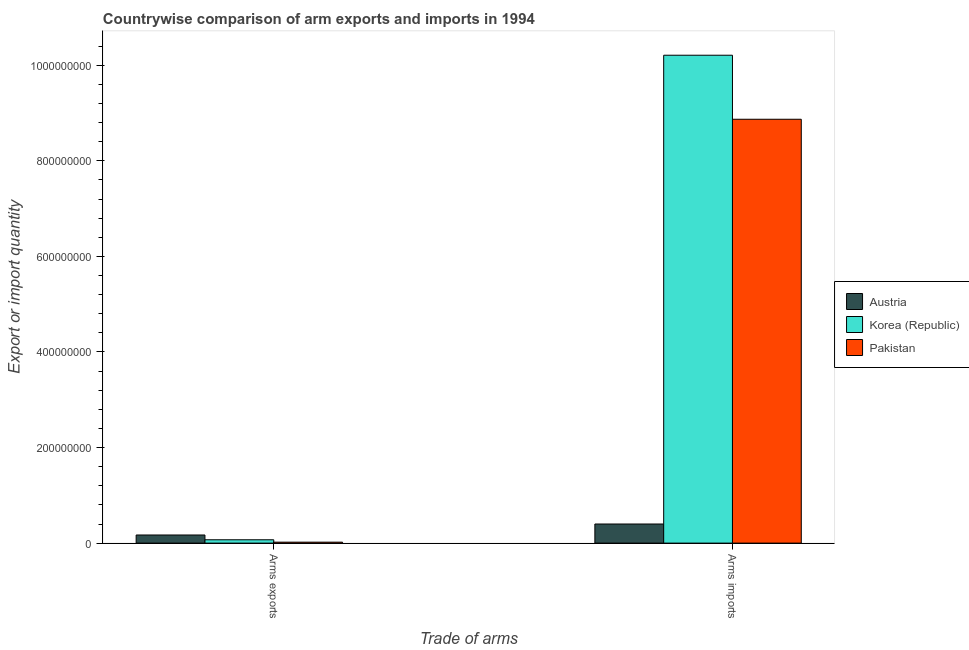Are the number of bars on each tick of the X-axis equal?
Your answer should be compact. Yes. What is the label of the 1st group of bars from the left?
Offer a very short reply. Arms exports. What is the arms imports in Korea (Republic)?
Offer a very short reply. 1.02e+09. Across all countries, what is the maximum arms imports?
Ensure brevity in your answer.  1.02e+09. Across all countries, what is the minimum arms exports?
Ensure brevity in your answer.  2.00e+06. What is the total arms imports in the graph?
Your answer should be very brief. 1.95e+09. What is the difference between the arms imports in Pakistan and that in Austria?
Give a very brief answer. 8.47e+08. What is the difference between the arms exports in Korea (Republic) and the arms imports in Austria?
Offer a very short reply. -3.30e+07. What is the average arms imports per country?
Offer a very short reply. 6.49e+08. What is the difference between the arms imports and arms exports in Pakistan?
Keep it short and to the point. 8.85e+08. What is the ratio of the arms imports in Pakistan to that in Austria?
Ensure brevity in your answer.  22.18. Is the arms imports in Korea (Republic) less than that in Austria?
Offer a terse response. No. What does the 1st bar from the left in Arms exports represents?
Provide a succinct answer. Austria. How many bars are there?
Your response must be concise. 6. Are all the bars in the graph horizontal?
Ensure brevity in your answer.  No. Are the values on the major ticks of Y-axis written in scientific E-notation?
Provide a succinct answer. No. Where does the legend appear in the graph?
Your answer should be very brief. Center right. How many legend labels are there?
Provide a short and direct response. 3. What is the title of the graph?
Keep it short and to the point. Countrywise comparison of arm exports and imports in 1994. What is the label or title of the X-axis?
Offer a very short reply. Trade of arms. What is the label or title of the Y-axis?
Provide a succinct answer. Export or import quantity. What is the Export or import quantity of Austria in Arms exports?
Your response must be concise. 1.70e+07. What is the Export or import quantity of Austria in Arms imports?
Ensure brevity in your answer.  4.00e+07. What is the Export or import quantity of Korea (Republic) in Arms imports?
Your answer should be compact. 1.02e+09. What is the Export or import quantity of Pakistan in Arms imports?
Offer a very short reply. 8.87e+08. Across all Trade of arms, what is the maximum Export or import quantity of Austria?
Give a very brief answer. 4.00e+07. Across all Trade of arms, what is the maximum Export or import quantity in Korea (Republic)?
Your answer should be very brief. 1.02e+09. Across all Trade of arms, what is the maximum Export or import quantity in Pakistan?
Offer a terse response. 8.87e+08. Across all Trade of arms, what is the minimum Export or import quantity of Austria?
Ensure brevity in your answer.  1.70e+07. Across all Trade of arms, what is the minimum Export or import quantity in Pakistan?
Offer a very short reply. 2.00e+06. What is the total Export or import quantity in Austria in the graph?
Your response must be concise. 5.70e+07. What is the total Export or import quantity in Korea (Republic) in the graph?
Ensure brevity in your answer.  1.03e+09. What is the total Export or import quantity of Pakistan in the graph?
Offer a very short reply. 8.89e+08. What is the difference between the Export or import quantity of Austria in Arms exports and that in Arms imports?
Give a very brief answer. -2.30e+07. What is the difference between the Export or import quantity in Korea (Republic) in Arms exports and that in Arms imports?
Offer a very short reply. -1.01e+09. What is the difference between the Export or import quantity of Pakistan in Arms exports and that in Arms imports?
Offer a terse response. -8.85e+08. What is the difference between the Export or import quantity in Austria in Arms exports and the Export or import quantity in Korea (Republic) in Arms imports?
Offer a terse response. -1.00e+09. What is the difference between the Export or import quantity in Austria in Arms exports and the Export or import quantity in Pakistan in Arms imports?
Provide a short and direct response. -8.70e+08. What is the difference between the Export or import quantity in Korea (Republic) in Arms exports and the Export or import quantity in Pakistan in Arms imports?
Your response must be concise. -8.80e+08. What is the average Export or import quantity of Austria per Trade of arms?
Provide a short and direct response. 2.85e+07. What is the average Export or import quantity in Korea (Republic) per Trade of arms?
Ensure brevity in your answer.  5.14e+08. What is the average Export or import quantity in Pakistan per Trade of arms?
Your response must be concise. 4.44e+08. What is the difference between the Export or import quantity of Austria and Export or import quantity of Pakistan in Arms exports?
Ensure brevity in your answer.  1.50e+07. What is the difference between the Export or import quantity of Austria and Export or import quantity of Korea (Republic) in Arms imports?
Offer a terse response. -9.81e+08. What is the difference between the Export or import quantity in Austria and Export or import quantity in Pakistan in Arms imports?
Provide a succinct answer. -8.47e+08. What is the difference between the Export or import quantity of Korea (Republic) and Export or import quantity of Pakistan in Arms imports?
Offer a terse response. 1.34e+08. What is the ratio of the Export or import quantity of Austria in Arms exports to that in Arms imports?
Your response must be concise. 0.42. What is the ratio of the Export or import quantity of Korea (Republic) in Arms exports to that in Arms imports?
Provide a short and direct response. 0.01. What is the ratio of the Export or import quantity of Pakistan in Arms exports to that in Arms imports?
Your answer should be very brief. 0. What is the difference between the highest and the second highest Export or import quantity of Austria?
Provide a short and direct response. 2.30e+07. What is the difference between the highest and the second highest Export or import quantity of Korea (Republic)?
Offer a very short reply. 1.01e+09. What is the difference between the highest and the second highest Export or import quantity in Pakistan?
Your answer should be very brief. 8.85e+08. What is the difference between the highest and the lowest Export or import quantity of Austria?
Provide a short and direct response. 2.30e+07. What is the difference between the highest and the lowest Export or import quantity in Korea (Republic)?
Ensure brevity in your answer.  1.01e+09. What is the difference between the highest and the lowest Export or import quantity of Pakistan?
Your response must be concise. 8.85e+08. 